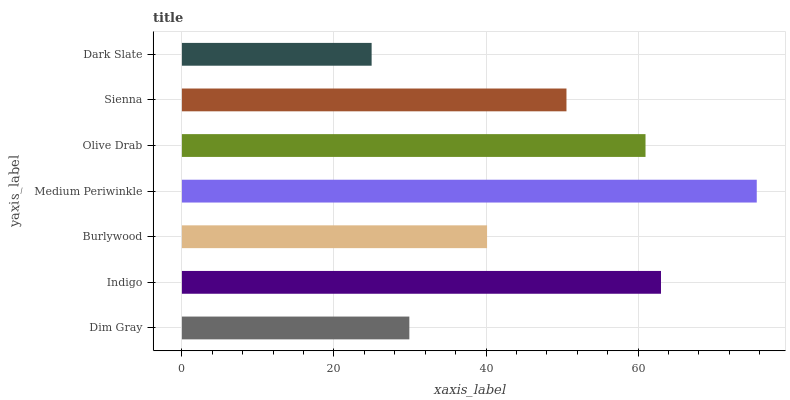Is Dark Slate the minimum?
Answer yes or no. Yes. Is Medium Periwinkle the maximum?
Answer yes or no. Yes. Is Indigo the minimum?
Answer yes or no. No. Is Indigo the maximum?
Answer yes or no. No. Is Indigo greater than Dim Gray?
Answer yes or no. Yes. Is Dim Gray less than Indigo?
Answer yes or no. Yes. Is Dim Gray greater than Indigo?
Answer yes or no. No. Is Indigo less than Dim Gray?
Answer yes or no. No. Is Sienna the high median?
Answer yes or no. Yes. Is Sienna the low median?
Answer yes or no. Yes. Is Dim Gray the high median?
Answer yes or no. No. Is Olive Drab the low median?
Answer yes or no. No. 